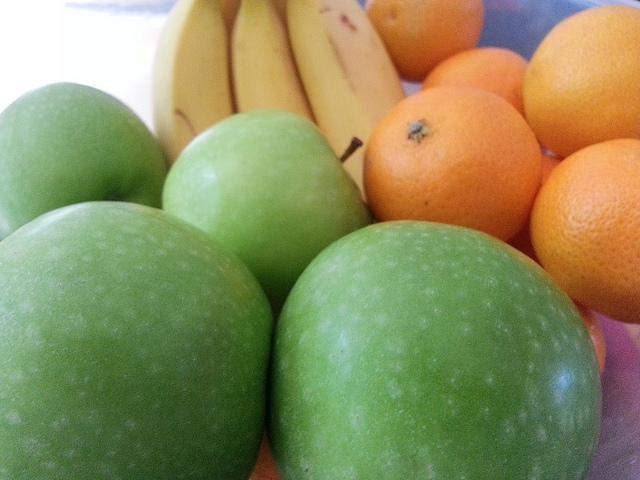What is the green item used in? apple pie 